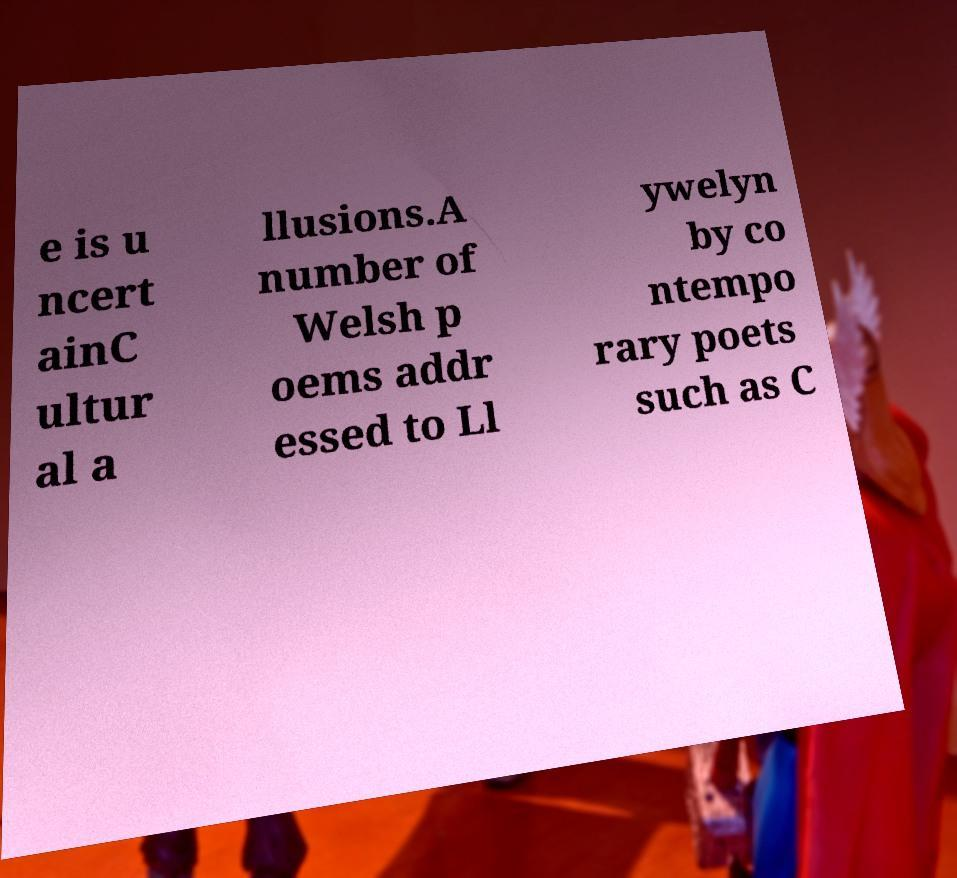I need the written content from this picture converted into text. Can you do that? e is u ncert ainC ultur al a llusions.A number of Welsh p oems addr essed to Ll ywelyn by co ntempo rary poets such as C 